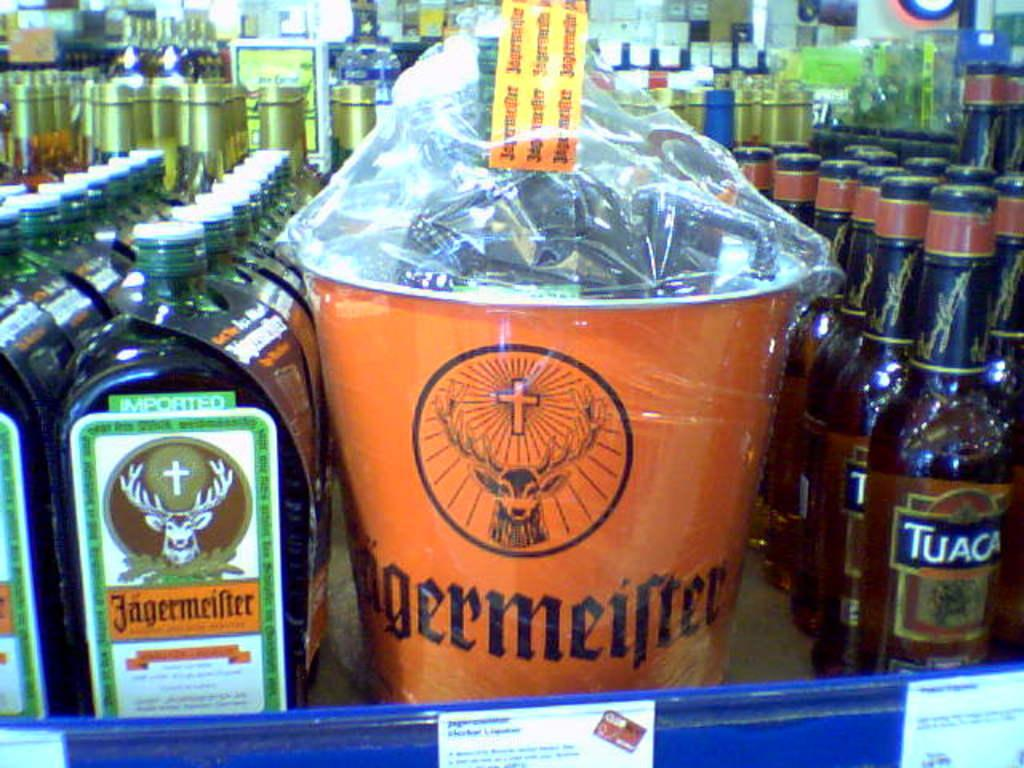Provide a one-sentence caption for the provided image. A few rows of Jagermeifer with a bucket in the middle of the rows containing Jagermeifer. 